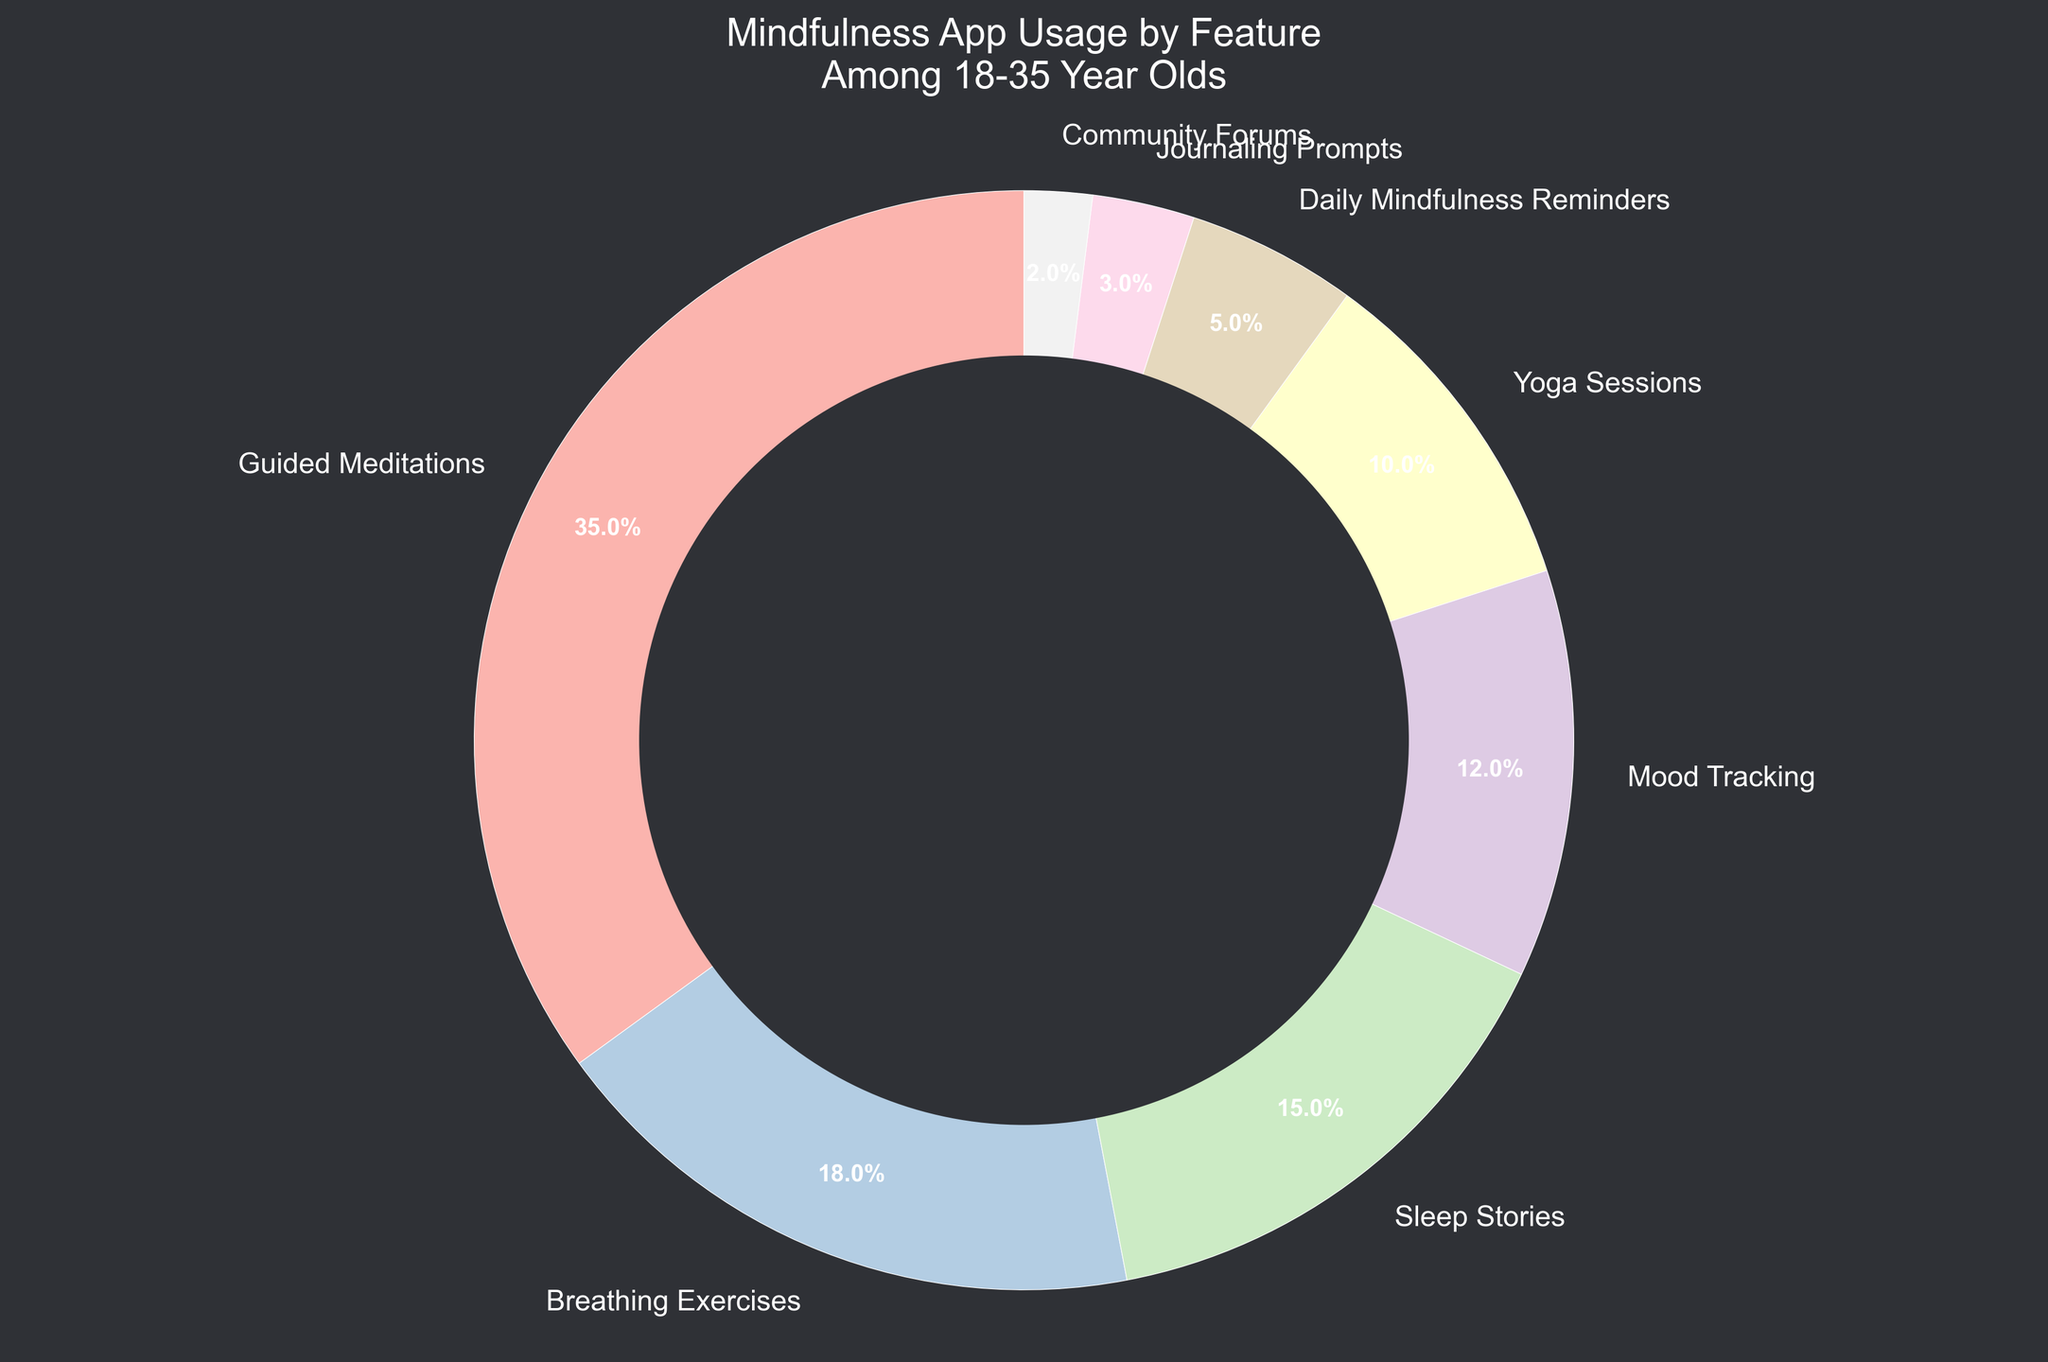Which feature has the highest usage percentage? The guided meditations feature has the highest usage percentage at 35%. This can be seen as the largest section of the pie chart.
Answer: Guided Meditations Which two features have the lowest combined usage percentage? The combined usage percentage of the community forums (2%) and journaling prompts (3%) is the lowest, totaling 5%.
Answer: Community Forums and Journaling Prompts How much more popular are guided meditations compared to yoga sessions? Guided meditations have a usage percentage of 35%, while yoga sessions have 10%. The difference is 35% - 10% = 25%.
Answer: 25% What is the total percentage usage of sleep-related features (sleep stories and breathing exercises)? The sleep stories feature has a usage of 15%, and breathing exercises have 18%. The combined total is 15% + 18% = 33%.
Answer: 33% How does the usage percentage of mood tracking compare to daily mindfulness reminders? Mood tracking has a usage percentage of 12%, and daily mindfulness reminders have 5%. Mood tracking is more used by 12% - 5% = 7%.
Answer: 7% What is the difference in usage percentage between the top three features (guided meditations, breathing exercises, and sleep stories) and the total of the remaining features? The top three features sum to 35% + 18% + 15% = 68%. The remaining features sum to 12% (mood tracking) + 10% (yoga sessions) + 5% (daily mindfulness reminders) + 3% (journaling prompts) + 2% (community forums) = 32%. The difference is 68% - 32% = 36%.
Answer: 36% If you combine the usage percentages of daily mindfulness reminders and journaling prompts, which other single feature has a similar percentage? Combining daily mindfulness reminders (5%) and journaling prompts (3%) gives 8%. This is close to the yoga sessions feature, which has 10%.
Answer: Yoga Sessions Which feature has a usage percentage that is triple that of community forums? Breathing exercises have a percentage of 18%, which is 2% * 3 = 6% more than community forums.
Answer: Breathing Exercises If guided meditations usage were to decrease by 5% and breathing exercises usage were to increase by 5%, which would have the higher percentage? After decreasing guided meditations by 5%, it would be 30%. After increasing breathing exercises by 5%, it would be 23%. Guided meditations would still be higher.
Answer: Guided Meditations What is the combined usage percentage of the features used for tracking and self-reflection (mood tracking and journaling prompts)? Mood tracking is 12% and journaling prompts are 3%, combining these gives 12% + 3% = 15%.
Answer: 15% 